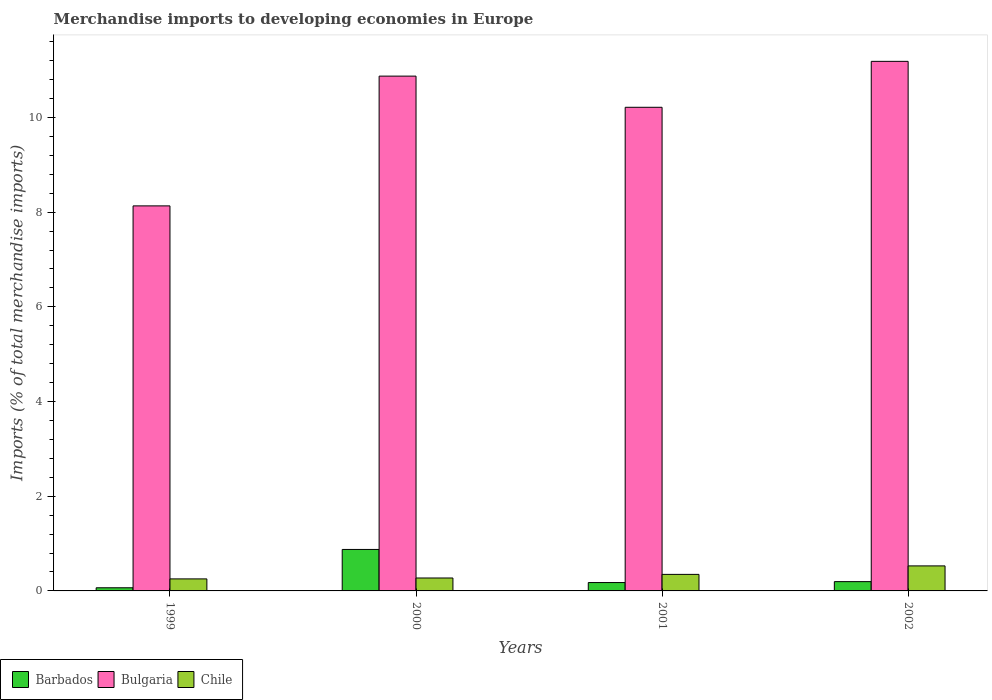How many different coloured bars are there?
Ensure brevity in your answer.  3. Are the number of bars per tick equal to the number of legend labels?
Provide a short and direct response. Yes. How many bars are there on the 1st tick from the left?
Keep it short and to the point. 3. How many bars are there on the 2nd tick from the right?
Give a very brief answer. 3. What is the percentage total merchandise imports in Bulgaria in 2001?
Your answer should be very brief. 10.21. Across all years, what is the maximum percentage total merchandise imports in Bulgaria?
Keep it short and to the point. 11.18. Across all years, what is the minimum percentage total merchandise imports in Bulgaria?
Your answer should be very brief. 8.13. In which year was the percentage total merchandise imports in Chile maximum?
Ensure brevity in your answer.  2002. In which year was the percentage total merchandise imports in Barbados minimum?
Your answer should be compact. 1999. What is the total percentage total merchandise imports in Chile in the graph?
Your response must be concise. 1.4. What is the difference between the percentage total merchandise imports in Chile in 2000 and that in 2001?
Your answer should be compact. -0.08. What is the difference between the percentage total merchandise imports in Chile in 2000 and the percentage total merchandise imports in Bulgaria in 1999?
Make the answer very short. -7.86. What is the average percentage total merchandise imports in Bulgaria per year?
Provide a short and direct response. 10.1. In the year 2000, what is the difference between the percentage total merchandise imports in Barbados and percentage total merchandise imports in Chile?
Provide a succinct answer. 0.6. What is the ratio of the percentage total merchandise imports in Chile in 2000 to that in 2002?
Offer a terse response. 0.52. Is the percentage total merchandise imports in Bulgaria in 1999 less than that in 2002?
Offer a terse response. Yes. What is the difference between the highest and the second highest percentage total merchandise imports in Barbados?
Your answer should be compact. 0.68. What is the difference between the highest and the lowest percentage total merchandise imports in Barbados?
Offer a very short reply. 0.81. In how many years, is the percentage total merchandise imports in Barbados greater than the average percentage total merchandise imports in Barbados taken over all years?
Make the answer very short. 1. Is the sum of the percentage total merchandise imports in Chile in 2000 and 2002 greater than the maximum percentage total merchandise imports in Bulgaria across all years?
Your answer should be compact. No. What does the 2nd bar from the left in 1999 represents?
Provide a succinct answer. Bulgaria. How many bars are there?
Your answer should be compact. 12. Are all the bars in the graph horizontal?
Provide a short and direct response. No. Does the graph contain any zero values?
Your response must be concise. No. Does the graph contain grids?
Offer a very short reply. No. How many legend labels are there?
Offer a very short reply. 3. What is the title of the graph?
Make the answer very short. Merchandise imports to developing economies in Europe. Does "Barbados" appear as one of the legend labels in the graph?
Your response must be concise. Yes. What is the label or title of the X-axis?
Your answer should be very brief. Years. What is the label or title of the Y-axis?
Your answer should be compact. Imports (% of total merchandise imports). What is the Imports (% of total merchandise imports) in Barbados in 1999?
Ensure brevity in your answer.  0.07. What is the Imports (% of total merchandise imports) in Bulgaria in 1999?
Ensure brevity in your answer.  8.13. What is the Imports (% of total merchandise imports) in Chile in 1999?
Provide a short and direct response. 0.25. What is the Imports (% of total merchandise imports) in Barbados in 2000?
Provide a short and direct response. 0.88. What is the Imports (% of total merchandise imports) in Bulgaria in 2000?
Your response must be concise. 10.87. What is the Imports (% of total merchandise imports) of Chile in 2000?
Keep it short and to the point. 0.27. What is the Imports (% of total merchandise imports) in Barbados in 2001?
Ensure brevity in your answer.  0.18. What is the Imports (% of total merchandise imports) of Bulgaria in 2001?
Ensure brevity in your answer.  10.21. What is the Imports (% of total merchandise imports) in Chile in 2001?
Provide a short and direct response. 0.35. What is the Imports (% of total merchandise imports) of Barbados in 2002?
Your response must be concise. 0.2. What is the Imports (% of total merchandise imports) of Bulgaria in 2002?
Your response must be concise. 11.18. What is the Imports (% of total merchandise imports) in Chile in 2002?
Provide a succinct answer. 0.53. Across all years, what is the maximum Imports (% of total merchandise imports) in Barbados?
Give a very brief answer. 0.88. Across all years, what is the maximum Imports (% of total merchandise imports) in Bulgaria?
Provide a succinct answer. 11.18. Across all years, what is the maximum Imports (% of total merchandise imports) in Chile?
Your answer should be compact. 0.53. Across all years, what is the minimum Imports (% of total merchandise imports) in Barbados?
Provide a succinct answer. 0.07. Across all years, what is the minimum Imports (% of total merchandise imports) of Bulgaria?
Provide a succinct answer. 8.13. Across all years, what is the minimum Imports (% of total merchandise imports) in Chile?
Give a very brief answer. 0.25. What is the total Imports (% of total merchandise imports) of Barbados in the graph?
Your answer should be very brief. 1.32. What is the total Imports (% of total merchandise imports) in Bulgaria in the graph?
Your answer should be very brief. 40.4. What is the total Imports (% of total merchandise imports) of Chile in the graph?
Offer a terse response. 1.4. What is the difference between the Imports (% of total merchandise imports) in Barbados in 1999 and that in 2000?
Offer a very short reply. -0.81. What is the difference between the Imports (% of total merchandise imports) in Bulgaria in 1999 and that in 2000?
Keep it short and to the point. -2.74. What is the difference between the Imports (% of total merchandise imports) of Chile in 1999 and that in 2000?
Offer a very short reply. -0.02. What is the difference between the Imports (% of total merchandise imports) of Barbados in 1999 and that in 2001?
Your response must be concise. -0.11. What is the difference between the Imports (% of total merchandise imports) of Bulgaria in 1999 and that in 2001?
Offer a very short reply. -2.08. What is the difference between the Imports (% of total merchandise imports) in Chile in 1999 and that in 2001?
Keep it short and to the point. -0.1. What is the difference between the Imports (% of total merchandise imports) of Barbados in 1999 and that in 2002?
Your response must be concise. -0.13. What is the difference between the Imports (% of total merchandise imports) of Bulgaria in 1999 and that in 2002?
Your answer should be compact. -3.05. What is the difference between the Imports (% of total merchandise imports) in Chile in 1999 and that in 2002?
Your answer should be very brief. -0.27. What is the difference between the Imports (% of total merchandise imports) of Barbados in 2000 and that in 2001?
Provide a succinct answer. 0.7. What is the difference between the Imports (% of total merchandise imports) of Bulgaria in 2000 and that in 2001?
Your response must be concise. 0.66. What is the difference between the Imports (% of total merchandise imports) of Chile in 2000 and that in 2001?
Offer a very short reply. -0.08. What is the difference between the Imports (% of total merchandise imports) in Barbados in 2000 and that in 2002?
Offer a terse response. 0.68. What is the difference between the Imports (% of total merchandise imports) in Bulgaria in 2000 and that in 2002?
Ensure brevity in your answer.  -0.31. What is the difference between the Imports (% of total merchandise imports) of Chile in 2000 and that in 2002?
Offer a terse response. -0.26. What is the difference between the Imports (% of total merchandise imports) in Barbados in 2001 and that in 2002?
Provide a short and direct response. -0.02. What is the difference between the Imports (% of total merchandise imports) in Bulgaria in 2001 and that in 2002?
Provide a short and direct response. -0.97. What is the difference between the Imports (% of total merchandise imports) of Chile in 2001 and that in 2002?
Provide a succinct answer. -0.18. What is the difference between the Imports (% of total merchandise imports) of Barbados in 1999 and the Imports (% of total merchandise imports) of Bulgaria in 2000?
Give a very brief answer. -10.81. What is the difference between the Imports (% of total merchandise imports) in Barbados in 1999 and the Imports (% of total merchandise imports) in Chile in 2000?
Your response must be concise. -0.21. What is the difference between the Imports (% of total merchandise imports) in Bulgaria in 1999 and the Imports (% of total merchandise imports) in Chile in 2000?
Provide a succinct answer. 7.86. What is the difference between the Imports (% of total merchandise imports) in Barbados in 1999 and the Imports (% of total merchandise imports) in Bulgaria in 2001?
Give a very brief answer. -10.15. What is the difference between the Imports (% of total merchandise imports) of Barbados in 1999 and the Imports (% of total merchandise imports) of Chile in 2001?
Your answer should be very brief. -0.28. What is the difference between the Imports (% of total merchandise imports) of Bulgaria in 1999 and the Imports (% of total merchandise imports) of Chile in 2001?
Your response must be concise. 7.78. What is the difference between the Imports (% of total merchandise imports) of Barbados in 1999 and the Imports (% of total merchandise imports) of Bulgaria in 2002?
Provide a short and direct response. -11.12. What is the difference between the Imports (% of total merchandise imports) of Barbados in 1999 and the Imports (% of total merchandise imports) of Chile in 2002?
Offer a terse response. -0.46. What is the difference between the Imports (% of total merchandise imports) in Bulgaria in 1999 and the Imports (% of total merchandise imports) in Chile in 2002?
Keep it short and to the point. 7.6. What is the difference between the Imports (% of total merchandise imports) of Barbados in 2000 and the Imports (% of total merchandise imports) of Bulgaria in 2001?
Offer a terse response. -9.34. What is the difference between the Imports (% of total merchandise imports) in Barbados in 2000 and the Imports (% of total merchandise imports) in Chile in 2001?
Your response must be concise. 0.53. What is the difference between the Imports (% of total merchandise imports) in Bulgaria in 2000 and the Imports (% of total merchandise imports) in Chile in 2001?
Offer a very short reply. 10.52. What is the difference between the Imports (% of total merchandise imports) in Barbados in 2000 and the Imports (% of total merchandise imports) in Bulgaria in 2002?
Keep it short and to the point. -10.31. What is the difference between the Imports (% of total merchandise imports) in Barbados in 2000 and the Imports (% of total merchandise imports) in Chile in 2002?
Ensure brevity in your answer.  0.35. What is the difference between the Imports (% of total merchandise imports) in Bulgaria in 2000 and the Imports (% of total merchandise imports) in Chile in 2002?
Ensure brevity in your answer.  10.34. What is the difference between the Imports (% of total merchandise imports) of Barbados in 2001 and the Imports (% of total merchandise imports) of Bulgaria in 2002?
Provide a succinct answer. -11.01. What is the difference between the Imports (% of total merchandise imports) of Barbados in 2001 and the Imports (% of total merchandise imports) of Chile in 2002?
Keep it short and to the point. -0.35. What is the difference between the Imports (% of total merchandise imports) in Bulgaria in 2001 and the Imports (% of total merchandise imports) in Chile in 2002?
Your response must be concise. 9.69. What is the average Imports (% of total merchandise imports) in Barbados per year?
Make the answer very short. 0.33. What is the average Imports (% of total merchandise imports) in Bulgaria per year?
Offer a very short reply. 10.1. What is the average Imports (% of total merchandise imports) of Chile per year?
Keep it short and to the point. 0.35. In the year 1999, what is the difference between the Imports (% of total merchandise imports) in Barbados and Imports (% of total merchandise imports) in Bulgaria?
Give a very brief answer. -8.07. In the year 1999, what is the difference between the Imports (% of total merchandise imports) in Barbados and Imports (% of total merchandise imports) in Chile?
Give a very brief answer. -0.19. In the year 1999, what is the difference between the Imports (% of total merchandise imports) in Bulgaria and Imports (% of total merchandise imports) in Chile?
Your answer should be compact. 7.88. In the year 2000, what is the difference between the Imports (% of total merchandise imports) of Barbados and Imports (% of total merchandise imports) of Bulgaria?
Provide a succinct answer. -10. In the year 2000, what is the difference between the Imports (% of total merchandise imports) in Barbados and Imports (% of total merchandise imports) in Chile?
Give a very brief answer. 0.6. In the year 2000, what is the difference between the Imports (% of total merchandise imports) in Bulgaria and Imports (% of total merchandise imports) in Chile?
Provide a short and direct response. 10.6. In the year 2001, what is the difference between the Imports (% of total merchandise imports) of Barbados and Imports (% of total merchandise imports) of Bulgaria?
Offer a very short reply. -10.04. In the year 2001, what is the difference between the Imports (% of total merchandise imports) of Barbados and Imports (% of total merchandise imports) of Chile?
Offer a very short reply. -0.17. In the year 2001, what is the difference between the Imports (% of total merchandise imports) in Bulgaria and Imports (% of total merchandise imports) in Chile?
Provide a succinct answer. 9.87. In the year 2002, what is the difference between the Imports (% of total merchandise imports) of Barbados and Imports (% of total merchandise imports) of Bulgaria?
Give a very brief answer. -10.99. In the year 2002, what is the difference between the Imports (% of total merchandise imports) of Barbados and Imports (% of total merchandise imports) of Chile?
Make the answer very short. -0.33. In the year 2002, what is the difference between the Imports (% of total merchandise imports) of Bulgaria and Imports (% of total merchandise imports) of Chile?
Make the answer very short. 10.66. What is the ratio of the Imports (% of total merchandise imports) of Barbados in 1999 to that in 2000?
Make the answer very short. 0.08. What is the ratio of the Imports (% of total merchandise imports) of Bulgaria in 1999 to that in 2000?
Provide a short and direct response. 0.75. What is the ratio of the Imports (% of total merchandise imports) of Chile in 1999 to that in 2000?
Make the answer very short. 0.93. What is the ratio of the Imports (% of total merchandise imports) of Barbados in 1999 to that in 2001?
Your answer should be compact. 0.38. What is the ratio of the Imports (% of total merchandise imports) of Bulgaria in 1999 to that in 2001?
Keep it short and to the point. 0.8. What is the ratio of the Imports (% of total merchandise imports) in Chile in 1999 to that in 2001?
Provide a succinct answer. 0.73. What is the ratio of the Imports (% of total merchandise imports) of Barbados in 1999 to that in 2002?
Your answer should be compact. 0.34. What is the ratio of the Imports (% of total merchandise imports) of Bulgaria in 1999 to that in 2002?
Provide a short and direct response. 0.73. What is the ratio of the Imports (% of total merchandise imports) of Chile in 1999 to that in 2002?
Offer a very short reply. 0.48. What is the ratio of the Imports (% of total merchandise imports) in Barbados in 2000 to that in 2001?
Give a very brief answer. 4.96. What is the ratio of the Imports (% of total merchandise imports) of Bulgaria in 2000 to that in 2001?
Ensure brevity in your answer.  1.06. What is the ratio of the Imports (% of total merchandise imports) in Chile in 2000 to that in 2001?
Offer a very short reply. 0.78. What is the ratio of the Imports (% of total merchandise imports) of Barbados in 2000 to that in 2002?
Offer a terse response. 4.46. What is the ratio of the Imports (% of total merchandise imports) in Bulgaria in 2000 to that in 2002?
Make the answer very short. 0.97. What is the ratio of the Imports (% of total merchandise imports) in Chile in 2000 to that in 2002?
Your response must be concise. 0.52. What is the ratio of the Imports (% of total merchandise imports) of Barbados in 2001 to that in 2002?
Make the answer very short. 0.9. What is the ratio of the Imports (% of total merchandise imports) in Bulgaria in 2001 to that in 2002?
Offer a very short reply. 0.91. What is the ratio of the Imports (% of total merchandise imports) in Chile in 2001 to that in 2002?
Offer a terse response. 0.66. What is the difference between the highest and the second highest Imports (% of total merchandise imports) in Barbados?
Give a very brief answer. 0.68. What is the difference between the highest and the second highest Imports (% of total merchandise imports) of Bulgaria?
Offer a terse response. 0.31. What is the difference between the highest and the second highest Imports (% of total merchandise imports) in Chile?
Your answer should be compact. 0.18. What is the difference between the highest and the lowest Imports (% of total merchandise imports) in Barbados?
Keep it short and to the point. 0.81. What is the difference between the highest and the lowest Imports (% of total merchandise imports) of Bulgaria?
Keep it short and to the point. 3.05. What is the difference between the highest and the lowest Imports (% of total merchandise imports) in Chile?
Provide a short and direct response. 0.27. 